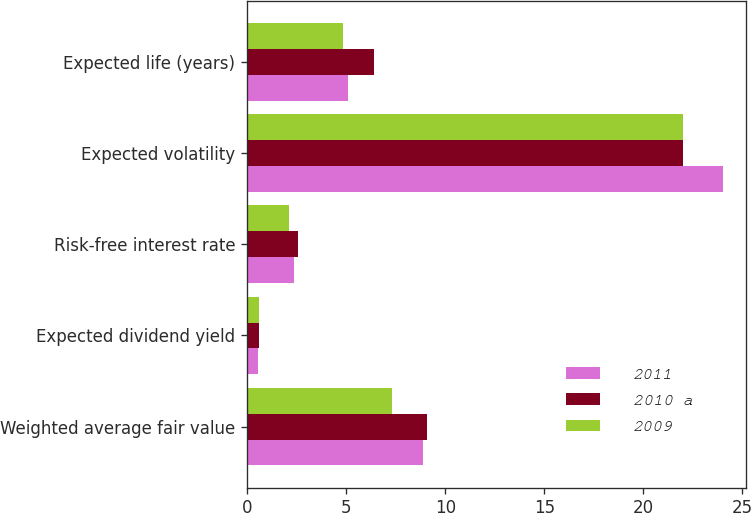<chart> <loc_0><loc_0><loc_500><loc_500><stacked_bar_chart><ecel><fcel>Weighted average fair value<fcel>Expected dividend yield<fcel>Risk-free interest rate<fcel>Expected volatility<fcel>Expected life (years)<nl><fcel>2011<fcel>8.86<fcel>0.55<fcel>2.35<fcel>24<fcel>5.07<nl><fcel>2010 a<fcel>9.06<fcel>0.58<fcel>2.55<fcel>22<fcel>6.42<nl><fcel>2009<fcel>7.31<fcel>0.6<fcel>2.14<fcel>22<fcel>4.84<nl></chart> 